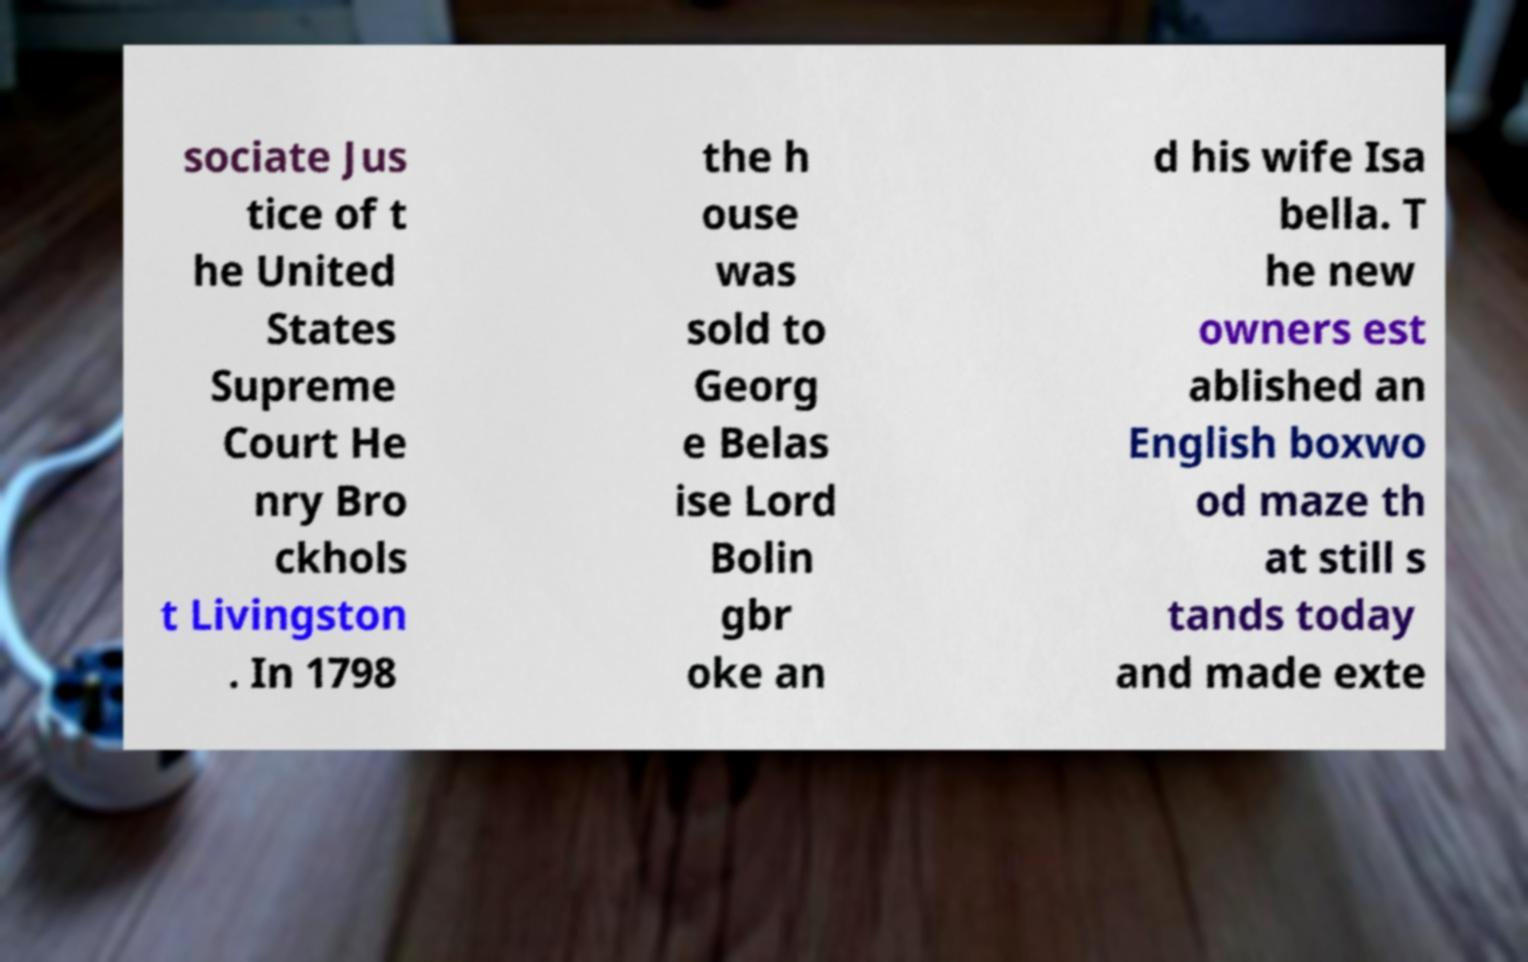Can you read and provide the text displayed in the image?This photo seems to have some interesting text. Can you extract and type it out for me? sociate Jus tice of t he United States Supreme Court He nry Bro ckhols t Livingston . In 1798 the h ouse was sold to Georg e Belas ise Lord Bolin gbr oke an d his wife Isa bella. T he new owners est ablished an English boxwo od maze th at still s tands today and made exte 